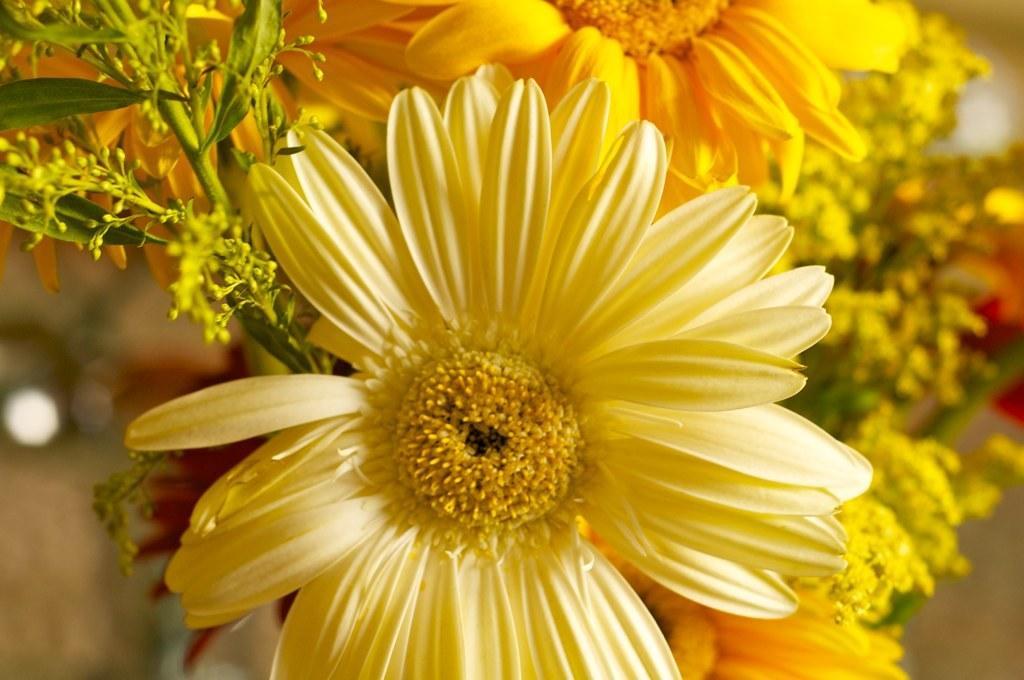Can you describe this image briefly? In this image, I can see the flowers, stems and leaves. The background is blurry. 